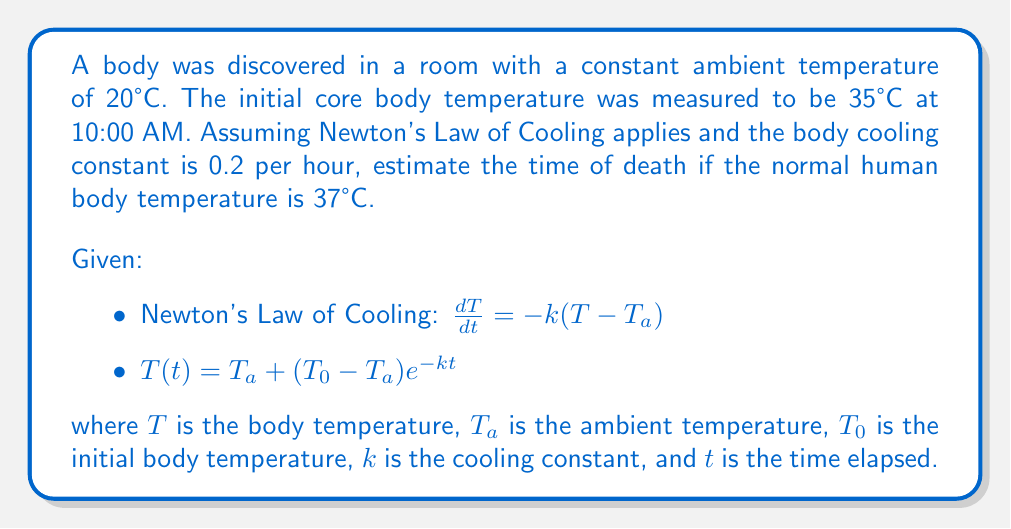Solve this math problem. To solve this inverse problem, we need to determine the time elapsed since death using the given information:

1. Set up the equation using Newton's Law of Cooling:
   $T(t) = T_a + (T_0 - T_a)e^{-kt}$

2. Substitute the known values:
   $35 = 20 + (37 - 20)e^{-0.2t}$

3. Simplify:
   $35 = 20 + 17e^{-0.2t}$

4. Subtract 20 from both sides:
   $15 = 17e^{-0.2t}$

5. Divide both sides by 17:
   $\frac{15}{17} = e^{-0.2t}$

6. Take the natural logarithm of both sides:
   $\ln(\frac{15}{17}) = -0.2t$

7. Solve for t:
   $t = -\frac{\ln(\frac{15}{17})}{0.2}$

8. Calculate the value of t:
   $t \approx 0.6265$ hours

9. Convert hours to minutes:
   $0.6265 \times 60 \approx 37.59$ minutes

10. Subtract this time from the discovery time (10:00 AM):
    10:00 AM - 37.59 minutes ≈ 9:22 AM

Therefore, the estimated time of death is approximately 9:22 AM.
Answer: 9:22 AM 